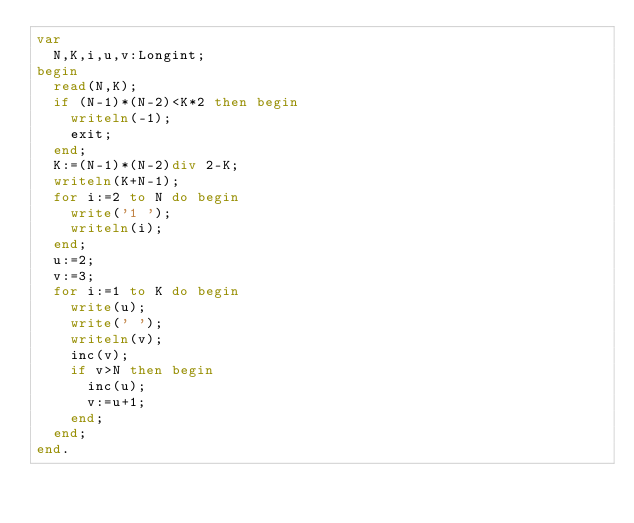<code> <loc_0><loc_0><loc_500><loc_500><_Pascal_>var
	N,K,i,u,v:Longint;
begin
	read(N,K);
	if (N-1)*(N-2)<K*2 then begin
		writeln(-1);
		exit;
	end;
	K:=(N-1)*(N-2)div 2-K;
	writeln(K+N-1);
	for i:=2 to N do begin
		write('1 ');
		writeln(i);
	end;
	u:=2;
	v:=3;
	for i:=1 to K do begin
		write(u);
		write(' ');
		writeln(v);
		inc(v);
		if v>N then begin
			inc(u);
			v:=u+1;
		end;
	end;
end.
</code> 